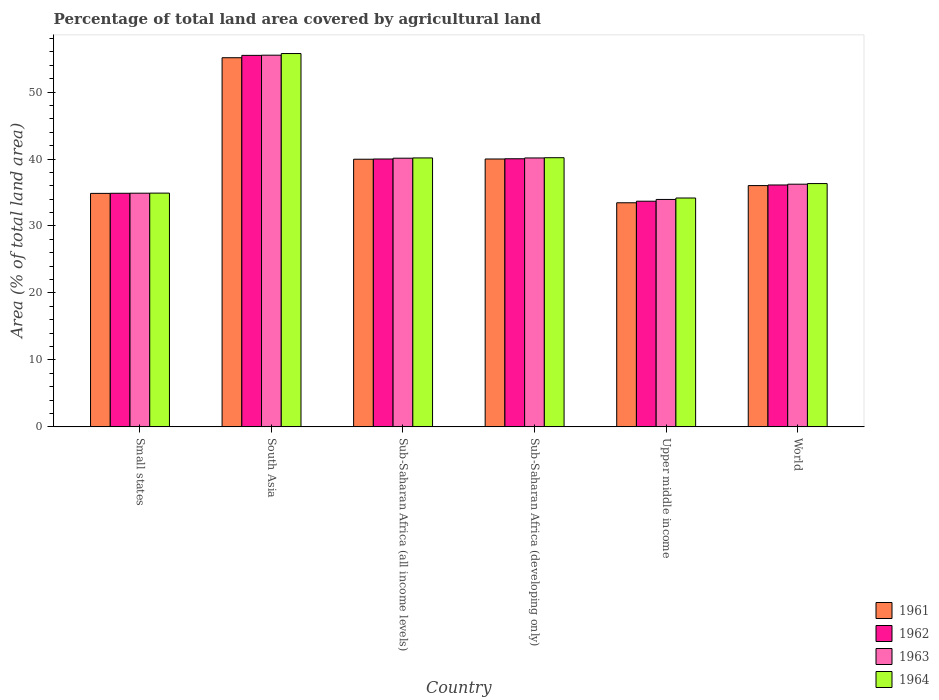How many different coloured bars are there?
Give a very brief answer. 4. How many groups of bars are there?
Ensure brevity in your answer.  6. Are the number of bars per tick equal to the number of legend labels?
Provide a succinct answer. Yes. How many bars are there on the 2nd tick from the left?
Provide a short and direct response. 4. How many bars are there on the 6th tick from the right?
Give a very brief answer. 4. What is the label of the 1st group of bars from the left?
Your response must be concise. Small states. What is the percentage of agricultural land in 1962 in South Asia?
Your answer should be very brief. 55.48. Across all countries, what is the maximum percentage of agricultural land in 1961?
Offer a very short reply. 55.13. Across all countries, what is the minimum percentage of agricultural land in 1963?
Provide a short and direct response. 33.96. In which country was the percentage of agricultural land in 1963 maximum?
Your response must be concise. South Asia. In which country was the percentage of agricultural land in 1962 minimum?
Give a very brief answer. Upper middle income. What is the total percentage of agricultural land in 1963 in the graph?
Ensure brevity in your answer.  240.89. What is the difference between the percentage of agricultural land in 1961 in Small states and that in Upper middle income?
Keep it short and to the point. 1.4. What is the difference between the percentage of agricultural land in 1962 in Sub-Saharan Africa (all income levels) and the percentage of agricultural land in 1964 in World?
Your answer should be very brief. 3.67. What is the average percentage of agricultural land in 1964 per country?
Your answer should be compact. 40.26. What is the difference between the percentage of agricultural land of/in 1964 and percentage of agricultural land of/in 1962 in Upper middle income?
Provide a short and direct response. 0.48. In how many countries, is the percentage of agricultural land in 1962 greater than 10 %?
Your response must be concise. 6. What is the ratio of the percentage of agricultural land in 1962 in Sub-Saharan Africa (all income levels) to that in Sub-Saharan Africa (developing only)?
Your answer should be compact. 1. Is the percentage of agricultural land in 1962 in Sub-Saharan Africa (all income levels) less than that in Upper middle income?
Keep it short and to the point. No. Is the difference between the percentage of agricultural land in 1964 in Small states and Sub-Saharan Africa (all income levels) greater than the difference between the percentage of agricultural land in 1962 in Small states and Sub-Saharan Africa (all income levels)?
Offer a terse response. No. What is the difference between the highest and the second highest percentage of agricultural land in 1964?
Provide a succinct answer. 0.03. What is the difference between the highest and the lowest percentage of agricultural land in 1964?
Make the answer very short. 21.57. In how many countries, is the percentage of agricultural land in 1961 greater than the average percentage of agricultural land in 1961 taken over all countries?
Provide a short and direct response. 3. Is it the case that in every country, the sum of the percentage of agricultural land in 1962 and percentage of agricultural land in 1964 is greater than the sum of percentage of agricultural land in 1963 and percentage of agricultural land in 1961?
Provide a succinct answer. No. What does the 4th bar from the left in Sub-Saharan Africa (all income levels) represents?
Make the answer very short. 1964. How many bars are there?
Your answer should be compact. 24. Are all the bars in the graph horizontal?
Your answer should be very brief. No. Are the values on the major ticks of Y-axis written in scientific E-notation?
Offer a very short reply. No. Where does the legend appear in the graph?
Your answer should be very brief. Bottom right. How are the legend labels stacked?
Ensure brevity in your answer.  Vertical. What is the title of the graph?
Your response must be concise. Percentage of total land area covered by agricultural land. Does "1987" appear as one of the legend labels in the graph?
Keep it short and to the point. No. What is the label or title of the Y-axis?
Give a very brief answer. Area (% of total land area). What is the Area (% of total land area) of 1961 in Small states?
Provide a short and direct response. 34.87. What is the Area (% of total land area) in 1962 in Small states?
Offer a very short reply. 34.88. What is the Area (% of total land area) in 1963 in Small states?
Provide a short and direct response. 34.9. What is the Area (% of total land area) of 1964 in Small states?
Ensure brevity in your answer.  34.91. What is the Area (% of total land area) of 1961 in South Asia?
Provide a short and direct response. 55.13. What is the Area (% of total land area) in 1962 in South Asia?
Offer a terse response. 55.48. What is the Area (% of total land area) of 1963 in South Asia?
Keep it short and to the point. 55.51. What is the Area (% of total land area) of 1964 in South Asia?
Give a very brief answer. 55.75. What is the Area (% of total land area) in 1961 in Sub-Saharan Africa (all income levels)?
Offer a terse response. 39.97. What is the Area (% of total land area) in 1962 in Sub-Saharan Africa (all income levels)?
Your answer should be very brief. 40. What is the Area (% of total land area) in 1963 in Sub-Saharan Africa (all income levels)?
Your answer should be very brief. 40.12. What is the Area (% of total land area) in 1964 in Sub-Saharan Africa (all income levels)?
Provide a succinct answer. 40.16. What is the Area (% of total land area) in 1961 in Sub-Saharan Africa (developing only)?
Your response must be concise. 40. What is the Area (% of total land area) in 1962 in Sub-Saharan Africa (developing only)?
Your answer should be compact. 40.04. What is the Area (% of total land area) of 1963 in Sub-Saharan Africa (developing only)?
Make the answer very short. 40.16. What is the Area (% of total land area) of 1964 in Sub-Saharan Africa (developing only)?
Ensure brevity in your answer.  40.2. What is the Area (% of total land area) in 1961 in Upper middle income?
Provide a succinct answer. 33.47. What is the Area (% of total land area) in 1962 in Upper middle income?
Offer a very short reply. 33.7. What is the Area (% of total land area) in 1963 in Upper middle income?
Provide a succinct answer. 33.96. What is the Area (% of total land area) of 1964 in Upper middle income?
Give a very brief answer. 34.18. What is the Area (% of total land area) of 1961 in World?
Provide a short and direct response. 36.03. What is the Area (% of total land area) of 1962 in World?
Offer a terse response. 36.12. What is the Area (% of total land area) of 1963 in World?
Provide a succinct answer. 36.24. What is the Area (% of total land area) in 1964 in World?
Your answer should be very brief. 36.33. Across all countries, what is the maximum Area (% of total land area) of 1961?
Give a very brief answer. 55.13. Across all countries, what is the maximum Area (% of total land area) in 1962?
Offer a very short reply. 55.48. Across all countries, what is the maximum Area (% of total land area) in 1963?
Offer a very short reply. 55.51. Across all countries, what is the maximum Area (% of total land area) of 1964?
Your response must be concise. 55.75. Across all countries, what is the minimum Area (% of total land area) in 1961?
Your response must be concise. 33.47. Across all countries, what is the minimum Area (% of total land area) in 1962?
Provide a short and direct response. 33.7. Across all countries, what is the minimum Area (% of total land area) of 1963?
Offer a terse response. 33.96. Across all countries, what is the minimum Area (% of total land area) in 1964?
Ensure brevity in your answer.  34.18. What is the total Area (% of total land area) in 1961 in the graph?
Ensure brevity in your answer.  239.47. What is the total Area (% of total land area) in 1962 in the graph?
Offer a very short reply. 240.23. What is the total Area (% of total land area) in 1963 in the graph?
Give a very brief answer. 240.89. What is the total Area (% of total land area) of 1964 in the graph?
Your response must be concise. 241.53. What is the difference between the Area (% of total land area) of 1961 in Small states and that in South Asia?
Make the answer very short. -20.26. What is the difference between the Area (% of total land area) of 1962 in Small states and that in South Asia?
Your response must be concise. -20.6. What is the difference between the Area (% of total land area) in 1963 in Small states and that in South Asia?
Give a very brief answer. -20.61. What is the difference between the Area (% of total land area) in 1964 in Small states and that in South Asia?
Your answer should be compact. -20.84. What is the difference between the Area (% of total land area) in 1961 in Small states and that in Sub-Saharan Africa (all income levels)?
Your answer should be compact. -5.1. What is the difference between the Area (% of total land area) in 1962 in Small states and that in Sub-Saharan Africa (all income levels)?
Offer a terse response. -5.12. What is the difference between the Area (% of total land area) in 1963 in Small states and that in Sub-Saharan Africa (all income levels)?
Give a very brief answer. -5.23. What is the difference between the Area (% of total land area) of 1964 in Small states and that in Sub-Saharan Africa (all income levels)?
Your answer should be compact. -5.25. What is the difference between the Area (% of total land area) of 1961 in Small states and that in Sub-Saharan Africa (developing only)?
Your answer should be compact. -5.13. What is the difference between the Area (% of total land area) of 1962 in Small states and that in Sub-Saharan Africa (developing only)?
Provide a short and direct response. -5.15. What is the difference between the Area (% of total land area) in 1963 in Small states and that in Sub-Saharan Africa (developing only)?
Provide a succinct answer. -5.26. What is the difference between the Area (% of total land area) in 1964 in Small states and that in Sub-Saharan Africa (developing only)?
Your answer should be compact. -5.29. What is the difference between the Area (% of total land area) in 1961 in Small states and that in Upper middle income?
Keep it short and to the point. 1.4. What is the difference between the Area (% of total land area) in 1962 in Small states and that in Upper middle income?
Make the answer very short. 1.18. What is the difference between the Area (% of total land area) of 1963 in Small states and that in Upper middle income?
Your answer should be compact. 0.93. What is the difference between the Area (% of total land area) of 1964 in Small states and that in Upper middle income?
Provide a short and direct response. 0.73. What is the difference between the Area (% of total land area) in 1961 in Small states and that in World?
Provide a short and direct response. -1.16. What is the difference between the Area (% of total land area) of 1962 in Small states and that in World?
Your response must be concise. -1.24. What is the difference between the Area (% of total land area) of 1963 in Small states and that in World?
Provide a succinct answer. -1.34. What is the difference between the Area (% of total land area) of 1964 in Small states and that in World?
Your response must be concise. -1.43. What is the difference between the Area (% of total land area) of 1961 in South Asia and that in Sub-Saharan Africa (all income levels)?
Provide a succinct answer. 15.16. What is the difference between the Area (% of total land area) of 1962 in South Asia and that in Sub-Saharan Africa (all income levels)?
Make the answer very short. 15.48. What is the difference between the Area (% of total land area) of 1963 in South Asia and that in Sub-Saharan Africa (all income levels)?
Your response must be concise. 15.38. What is the difference between the Area (% of total land area) of 1964 in South Asia and that in Sub-Saharan Africa (all income levels)?
Keep it short and to the point. 15.59. What is the difference between the Area (% of total land area) of 1961 in South Asia and that in Sub-Saharan Africa (developing only)?
Keep it short and to the point. 15.12. What is the difference between the Area (% of total land area) in 1962 in South Asia and that in Sub-Saharan Africa (developing only)?
Provide a succinct answer. 15.44. What is the difference between the Area (% of total land area) of 1963 in South Asia and that in Sub-Saharan Africa (developing only)?
Ensure brevity in your answer.  15.35. What is the difference between the Area (% of total land area) of 1964 in South Asia and that in Sub-Saharan Africa (developing only)?
Give a very brief answer. 15.56. What is the difference between the Area (% of total land area) of 1961 in South Asia and that in Upper middle income?
Offer a very short reply. 21.66. What is the difference between the Area (% of total land area) of 1962 in South Asia and that in Upper middle income?
Your answer should be compact. 21.78. What is the difference between the Area (% of total land area) in 1963 in South Asia and that in Upper middle income?
Provide a short and direct response. 21.54. What is the difference between the Area (% of total land area) of 1964 in South Asia and that in Upper middle income?
Your answer should be compact. 21.57. What is the difference between the Area (% of total land area) of 1961 in South Asia and that in World?
Your answer should be compact. 19.1. What is the difference between the Area (% of total land area) of 1962 in South Asia and that in World?
Make the answer very short. 19.36. What is the difference between the Area (% of total land area) of 1963 in South Asia and that in World?
Provide a succinct answer. 19.27. What is the difference between the Area (% of total land area) of 1964 in South Asia and that in World?
Keep it short and to the point. 19.42. What is the difference between the Area (% of total land area) in 1961 in Sub-Saharan Africa (all income levels) and that in Sub-Saharan Africa (developing only)?
Your response must be concise. -0.03. What is the difference between the Area (% of total land area) in 1962 in Sub-Saharan Africa (all income levels) and that in Sub-Saharan Africa (developing only)?
Your answer should be very brief. -0.03. What is the difference between the Area (% of total land area) of 1963 in Sub-Saharan Africa (all income levels) and that in Sub-Saharan Africa (developing only)?
Offer a terse response. -0.03. What is the difference between the Area (% of total land area) in 1964 in Sub-Saharan Africa (all income levels) and that in Sub-Saharan Africa (developing only)?
Provide a short and direct response. -0.03. What is the difference between the Area (% of total land area) in 1961 in Sub-Saharan Africa (all income levels) and that in Upper middle income?
Your answer should be very brief. 6.5. What is the difference between the Area (% of total land area) of 1962 in Sub-Saharan Africa (all income levels) and that in Upper middle income?
Your response must be concise. 6.3. What is the difference between the Area (% of total land area) of 1963 in Sub-Saharan Africa (all income levels) and that in Upper middle income?
Provide a short and direct response. 6.16. What is the difference between the Area (% of total land area) in 1964 in Sub-Saharan Africa (all income levels) and that in Upper middle income?
Offer a very short reply. 5.98. What is the difference between the Area (% of total land area) in 1961 in Sub-Saharan Africa (all income levels) and that in World?
Your response must be concise. 3.94. What is the difference between the Area (% of total land area) of 1962 in Sub-Saharan Africa (all income levels) and that in World?
Your answer should be very brief. 3.88. What is the difference between the Area (% of total land area) of 1963 in Sub-Saharan Africa (all income levels) and that in World?
Offer a very short reply. 3.88. What is the difference between the Area (% of total land area) of 1964 in Sub-Saharan Africa (all income levels) and that in World?
Give a very brief answer. 3.83. What is the difference between the Area (% of total land area) of 1961 in Sub-Saharan Africa (developing only) and that in Upper middle income?
Offer a terse response. 6.54. What is the difference between the Area (% of total land area) of 1962 in Sub-Saharan Africa (developing only) and that in Upper middle income?
Provide a short and direct response. 6.34. What is the difference between the Area (% of total land area) of 1963 in Sub-Saharan Africa (developing only) and that in Upper middle income?
Your answer should be compact. 6.2. What is the difference between the Area (% of total land area) of 1964 in Sub-Saharan Africa (developing only) and that in Upper middle income?
Offer a very short reply. 6.02. What is the difference between the Area (% of total land area) of 1961 in Sub-Saharan Africa (developing only) and that in World?
Give a very brief answer. 3.97. What is the difference between the Area (% of total land area) of 1962 in Sub-Saharan Africa (developing only) and that in World?
Offer a terse response. 3.91. What is the difference between the Area (% of total land area) in 1963 in Sub-Saharan Africa (developing only) and that in World?
Make the answer very short. 3.92. What is the difference between the Area (% of total land area) in 1964 in Sub-Saharan Africa (developing only) and that in World?
Make the answer very short. 3.86. What is the difference between the Area (% of total land area) in 1961 in Upper middle income and that in World?
Ensure brevity in your answer.  -2.57. What is the difference between the Area (% of total land area) in 1962 in Upper middle income and that in World?
Your response must be concise. -2.42. What is the difference between the Area (% of total land area) of 1963 in Upper middle income and that in World?
Give a very brief answer. -2.28. What is the difference between the Area (% of total land area) of 1964 in Upper middle income and that in World?
Your answer should be very brief. -2.15. What is the difference between the Area (% of total land area) in 1961 in Small states and the Area (% of total land area) in 1962 in South Asia?
Provide a succinct answer. -20.61. What is the difference between the Area (% of total land area) of 1961 in Small states and the Area (% of total land area) of 1963 in South Asia?
Your response must be concise. -20.64. What is the difference between the Area (% of total land area) in 1961 in Small states and the Area (% of total land area) in 1964 in South Asia?
Your answer should be very brief. -20.88. What is the difference between the Area (% of total land area) of 1962 in Small states and the Area (% of total land area) of 1963 in South Asia?
Your response must be concise. -20.62. What is the difference between the Area (% of total land area) in 1962 in Small states and the Area (% of total land area) in 1964 in South Asia?
Keep it short and to the point. -20.87. What is the difference between the Area (% of total land area) of 1963 in Small states and the Area (% of total land area) of 1964 in South Asia?
Keep it short and to the point. -20.86. What is the difference between the Area (% of total land area) of 1961 in Small states and the Area (% of total land area) of 1962 in Sub-Saharan Africa (all income levels)?
Your answer should be compact. -5.13. What is the difference between the Area (% of total land area) in 1961 in Small states and the Area (% of total land area) in 1963 in Sub-Saharan Africa (all income levels)?
Your response must be concise. -5.25. What is the difference between the Area (% of total land area) in 1961 in Small states and the Area (% of total land area) in 1964 in Sub-Saharan Africa (all income levels)?
Provide a succinct answer. -5.29. What is the difference between the Area (% of total land area) of 1962 in Small states and the Area (% of total land area) of 1963 in Sub-Saharan Africa (all income levels)?
Make the answer very short. -5.24. What is the difference between the Area (% of total land area) of 1962 in Small states and the Area (% of total land area) of 1964 in Sub-Saharan Africa (all income levels)?
Make the answer very short. -5.28. What is the difference between the Area (% of total land area) of 1963 in Small states and the Area (% of total land area) of 1964 in Sub-Saharan Africa (all income levels)?
Offer a very short reply. -5.27. What is the difference between the Area (% of total land area) in 1961 in Small states and the Area (% of total land area) in 1962 in Sub-Saharan Africa (developing only)?
Give a very brief answer. -5.17. What is the difference between the Area (% of total land area) in 1961 in Small states and the Area (% of total land area) in 1963 in Sub-Saharan Africa (developing only)?
Your response must be concise. -5.29. What is the difference between the Area (% of total land area) of 1961 in Small states and the Area (% of total land area) of 1964 in Sub-Saharan Africa (developing only)?
Keep it short and to the point. -5.33. What is the difference between the Area (% of total land area) in 1962 in Small states and the Area (% of total land area) in 1963 in Sub-Saharan Africa (developing only)?
Give a very brief answer. -5.27. What is the difference between the Area (% of total land area) in 1962 in Small states and the Area (% of total land area) in 1964 in Sub-Saharan Africa (developing only)?
Offer a very short reply. -5.31. What is the difference between the Area (% of total land area) in 1963 in Small states and the Area (% of total land area) in 1964 in Sub-Saharan Africa (developing only)?
Keep it short and to the point. -5.3. What is the difference between the Area (% of total land area) of 1961 in Small states and the Area (% of total land area) of 1962 in Upper middle income?
Offer a terse response. 1.17. What is the difference between the Area (% of total land area) in 1961 in Small states and the Area (% of total land area) in 1963 in Upper middle income?
Give a very brief answer. 0.91. What is the difference between the Area (% of total land area) in 1961 in Small states and the Area (% of total land area) in 1964 in Upper middle income?
Give a very brief answer. 0.69. What is the difference between the Area (% of total land area) in 1962 in Small states and the Area (% of total land area) in 1963 in Upper middle income?
Make the answer very short. 0.92. What is the difference between the Area (% of total land area) of 1962 in Small states and the Area (% of total land area) of 1964 in Upper middle income?
Ensure brevity in your answer.  0.71. What is the difference between the Area (% of total land area) of 1963 in Small states and the Area (% of total land area) of 1964 in Upper middle income?
Provide a succinct answer. 0.72. What is the difference between the Area (% of total land area) in 1961 in Small states and the Area (% of total land area) in 1962 in World?
Your answer should be compact. -1.25. What is the difference between the Area (% of total land area) in 1961 in Small states and the Area (% of total land area) in 1963 in World?
Make the answer very short. -1.37. What is the difference between the Area (% of total land area) of 1961 in Small states and the Area (% of total land area) of 1964 in World?
Ensure brevity in your answer.  -1.46. What is the difference between the Area (% of total land area) of 1962 in Small states and the Area (% of total land area) of 1963 in World?
Your answer should be compact. -1.36. What is the difference between the Area (% of total land area) of 1962 in Small states and the Area (% of total land area) of 1964 in World?
Provide a succinct answer. -1.45. What is the difference between the Area (% of total land area) of 1963 in Small states and the Area (% of total land area) of 1964 in World?
Offer a terse response. -1.44. What is the difference between the Area (% of total land area) in 1961 in South Asia and the Area (% of total land area) in 1962 in Sub-Saharan Africa (all income levels)?
Your response must be concise. 15.12. What is the difference between the Area (% of total land area) in 1961 in South Asia and the Area (% of total land area) in 1963 in Sub-Saharan Africa (all income levels)?
Ensure brevity in your answer.  15. What is the difference between the Area (% of total land area) of 1961 in South Asia and the Area (% of total land area) of 1964 in Sub-Saharan Africa (all income levels)?
Your response must be concise. 14.97. What is the difference between the Area (% of total land area) in 1962 in South Asia and the Area (% of total land area) in 1963 in Sub-Saharan Africa (all income levels)?
Provide a succinct answer. 15.36. What is the difference between the Area (% of total land area) of 1962 in South Asia and the Area (% of total land area) of 1964 in Sub-Saharan Africa (all income levels)?
Provide a succinct answer. 15.32. What is the difference between the Area (% of total land area) in 1963 in South Asia and the Area (% of total land area) in 1964 in Sub-Saharan Africa (all income levels)?
Keep it short and to the point. 15.35. What is the difference between the Area (% of total land area) in 1961 in South Asia and the Area (% of total land area) in 1962 in Sub-Saharan Africa (developing only)?
Provide a succinct answer. 15.09. What is the difference between the Area (% of total land area) of 1961 in South Asia and the Area (% of total land area) of 1963 in Sub-Saharan Africa (developing only)?
Your answer should be compact. 14.97. What is the difference between the Area (% of total land area) of 1961 in South Asia and the Area (% of total land area) of 1964 in Sub-Saharan Africa (developing only)?
Offer a terse response. 14.93. What is the difference between the Area (% of total land area) in 1962 in South Asia and the Area (% of total land area) in 1963 in Sub-Saharan Africa (developing only)?
Offer a terse response. 15.32. What is the difference between the Area (% of total land area) of 1962 in South Asia and the Area (% of total land area) of 1964 in Sub-Saharan Africa (developing only)?
Your response must be concise. 15.28. What is the difference between the Area (% of total land area) in 1963 in South Asia and the Area (% of total land area) in 1964 in Sub-Saharan Africa (developing only)?
Give a very brief answer. 15.31. What is the difference between the Area (% of total land area) of 1961 in South Asia and the Area (% of total land area) of 1962 in Upper middle income?
Offer a very short reply. 21.43. What is the difference between the Area (% of total land area) in 1961 in South Asia and the Area (% of total land area) in 1963 in Upper middle income?
Ensure brevity in your answer.  21.17. What is the difference between the Area (% of total land area) in 1961 in South Asia and the Area (% of total land area) in 1964 in Upper middle income?
Offer a very short reply. 20.95. What is the difference between the Area (% of total land area) of 1962 in South Asia and the Area (% of total land area) of 1963 in Upper middle income?
Provide a succinct answer. 21.52. What is the difference between the Area (% of total land area) in 1962 in South Asia and the Area (% of total land area) in 1964 in Upper middle income?
Ensure brevity in your answer.  21.3. What is the difference between the Area (% of total land area) of 1963 in South Asia and the Area (% of total land area) of 1964 in Upper middle income?
Provide a succinct answer. 21.33. What is the difference between the Area (% of total land area) in 1961 in South Asia and the Area (% of total land area) in 1962 in World?
Provide a succinct answer. 19. What is the difference between the Area (% of total land area) of 1961 in South Asia and the Area (% of total land area) of 1963 in World?
Ensure brevity in your answer.  18.89. What is the difference between the Area (% of total land area) of 1961 in South Asia and the Area (% of total land area) of 1964 in World?
Make the answer very short. 18.79. What is the difference between the Area (% of total land area) in 1962 in South Asia and the Area (% of total land area) in 1963 in World?
Provide a succinct answer. 19.24. What is the difference between the Area (% of total land area) in 1962 in South Asia and the Area (% of total land area) in 1964 in World?
Give a very brief answer. 19.15. What is the difference between the Area (% of total land area) in 1963 in South Asia and the Area (% of total land area) in 1964 in World?
Make the answer very short. 19.17. What is the difference between the Area (% of total land area) in 1961 in Sub-Saharan Africa (all income levels) and the Area (% of total land area) in 1962 in Sub-Saharan Africa (developing only)?
Provide a short and direct response. -0.07. What is the difference between the Area (% of total land area) of 1961 in Sub-Saharan Africa (all income levels) and the Area (% of total land area) of 1963 in Sub-Saharan Africa (developing only)?
Give a very brief answer. -0.19. What is the difference between the Area (% of total land area) in 1961 in Sub-Saharan Africa (all income levels) and the Area (% of total land area) in 1964 in Sub-Saharan Africa (developing only)?
Keep it short and to the point. -0.23. What is the difference between the Area (% of total land area) in 1962 in Sub-Saharan Africa (all income levels) and the Area (% of total land area) in 1963 in Sub-Saharan Africa (developing only)?
Provide a succinct answer. -0.15. What is the difference between the Area (% of total land area) of 1962 in Sub-Saharan Africa (all income levels) and the Area (% of total land area) of 1964 in Sub-Saharan Africa (developing only)?
Give a very brief answer. -0.19. What is the difference between the Area (% of total land area) of 1963 in Sub-Saharan Africa (all income levels) and the Area (% of total land area) of 1964 in Sub-Saharan Africa (developing only)?
Offer a very short reply. -0.07. What is the difference between the Area (% of total land area) of 1961 in Sub-Saharan Africa (all income levels) and the Area (% of total land area) of 1962 in Upper middle income?
Provide a short and direct response. 6.27. What is the difference between the Area (% of total land area) of 1961 in Sub-Saharan Africa (all income levels) and the Area (% of total land area) of 1963 in Upper middle income?
Offer a very short reply. 6.01. What is the difference between the Area (% of total land area) in 1961 in Sub-Saharan Africa (all income levels) and the Area (% of total land area) in 1964 in Upper middle income?
Your answer should be very brief. 5.79. What is the difference between the Area (% of total land area) in 1962 in Sub-Saharan Africa (all income levels) and the Area (% of total land area) in 1963 in Upper middle income?
Offer a very short reply. 6.04. What is the difference between the Area (% of total land area) in 1962 in Sub-Saharan Africa (all income levels) and the Area (% of total land area) in 1964 in Upper middle income?
Give a very brief answer. 5.82. What is the difference between the Area (% of total land area) of 1963 in Sub-Saharan Africa (all income levels) and the Area (% of total land area) of 1964 in Upper middle income?
Keep it short and to the point. 5.95. What is the difference between the Area (% of total land area) in 1961 in Sub-Saharan Africa (all income levels) and the Area (% of total land area) in 1962 in World?
Your answer should be very brief. 3.84. What is the difference between the Area (% of total land area) in 1961 in Sub-Saharan Africa (all income levels) and the Area (% of total land area) in 1963 in World?
Give a very brief answer. 3.73. What is the difference between the Area (% of total land area) of 1961 in Sub-Saharan Africa (all income levels) and the Area (% of total land area) of 1964 in World?
Keep it short and to the point. 3.64. What is the difference between the Area (% of total land area) of 1962 in Sub-Saharan Africa (all income levels) and the Area (% of total land area) of 1963 in World?
Provide a short and direct response. 3.76. What is the difference between the Area (% of total land area) of 1962 in Sub-Saharan Africa (all income levels) and the Area (% of total land area) of 1964 in World?
Your answer should be compact. 3.67. What is the difference between the Area (% of total land area) in 1963 in Sub-Saharan Africa (all income levels) and the Area (% of total land area) in 1964 in World?
Your answer should be compact. 3.79. What is the difference between the Area (% of total land area) of 1961 in Sub-Saharan Africa (developing only) and the Area (% of total land area) of 1962 in Upper middle income?
Your response must be concise. 6.3. What is the difference between the Area (% of total land area) of 1961 in Sub-Saharan Africa (developing only) and the Area (% of total land area) of 1963 in Upper middle income?
Provide a short and direct response. 6.04. What is the difference between the Area (% of total land area) of 1961 in Sub-Saharan Africa (developing only) and the Area (% of total land area) of 1964 in Upper middle income?
Offer a terse response. 5.82. What is the difference between the Area (% of total land area) in 1962 in Sub-Saharan Africa (developing only) and the Area (% of total land area) in 1963 in Upper middle income?
Provide a succinct answer. 6.08. What is the difference between the Area (% of total land area) in 1962 in Sub-Saharan Africa (developing only) and the Area (% of total land area) in 1964 in Upper middle income?
Provide a short and direct response. 5.86. What is the difference between the Area (% of total land area) of 1963 in Sub-Saharan Africa (developing only) and the Area (% of total land area) of 1964 in Upper middle income?
Offer a very short reply. 5.98. What is the difference between the Area (% of total land area) in 1961 in Sub-Saharan Africa (developing only) and the Area (% of total land area) in 1962 in World?
Ensure brevity in your answer.  3.88. What is the difference between the Area (% of total land area) in 1961 in Sub-Saharan Africa (developing only) and the Area (% of total land area) in 1963 in World?
Your response must be concise. 3.76. What is the difference between the Area (% of total land area) of 1961 in Sub-Saharan Africa (developing only) and the Area (% of total land area) of 1964 in World?
Offer a very short reply. 3.67. What is the difference between the Area (% of total land area) in 1962 in Sub-Saharan Africa (developing only) and the Area (% of total land area) in 1963 in World?
Your answer should be compact. 3.8. What is the difference between the Area (% of total land area) of 1962 in Sub-Saharan Africa (developing only) and the Area (% of total land area) of 1964 in World?
Your answer should be compact. 3.7. What is the difference between the Area (% of total land area) of 1963 in Sub-Saharan Africa (developing only) and the Area (% of total land area) of 1964 in World?
Provide a short and direct response. 3.83. What is the difference between the Area (% of total land area) in 1961 in Upper middle income and the Area (% of total land area) in 1962 in World?
Ensure brevity in your answer.  -2.66. What is the difference between the Area (% of total land area) in 1961 in Upper middle income and the Area (% of total land area) in 1963 in World?
Your response must be concise. -2.77. What is the difference between the Area (% of total land area) of 1961 in Upper middle income and the Area (% of total land area) of 1964 in World?
Keep it short and to the point. -2.87. What is the difference between the Area (% of total land area) in 1962 in Upper middle income and the Area (% of total land area) in 1963 in World?
Provide a succinct answer. -2.54. What is the difference between the Area (% of total land area) of 1962 in Upper middle income and the Area (% of total land area) of 1964 in World?
Ensure brevity in your answer.  -2.63. What is the difference between the Area (% of total land area) of 1963 in Upper middle income and the Area (% of total land area) of 1964 in World?
Provide a short and direct response. -2.37. What is the average Area (% of total land area) in 1961 per country?
Offer a terse response. 39.91. What is the average Area (% of total land area) in 1962 per country?
Give a very brief answer. 40.04. What is the average Area (% of total land area) in 1963 per country?
Provide a succinct answer. 40.15. What is the average Area (% of total land area) of 1964 per country?
Your answer should be compact. 40.26. What is the difference between the Area (% of total land area) of 1961 and Area (% of total land area) of 1962 in Small states?
Offer a terse response. -0.01. What is the difference between the Area (% of total land area) of 1961 and Area (% of total land area) of 1963 in Small states?
Offer a very short reply. -0.03. What is the difference between the Area (% of total land area) in 1961 and Area (% of total land area) in 1964 in Small states?
Provide a short and direct response. -0.04. What is the difference between the Area (% of total land area) of 1962 and Area (% of total land area) of 1963 in Small states?
Keep it short and to the point. -0.01. What is the difference between the Area (% of total land area) in 1962 and Area (% of total land area) in 1964 in Small states?
Make the answer very short. -0.02. What is the difference between the Area (% of total land area) of 1963 and Area (% of total land area) of 1964 in Small states?
Ensure brevity in your answer.  -0.01. What is the difference between the Area (% of total land area) of 1961 and Area (% of total land area) of 1962 in South Asia?
Make the answer very short. -0.35. What is the difference between the Area (% of total land area) in 1961 and Area (% of total land area) in 1963 in South Asia?
Make the answer very short. -0.38. What is the difference between the Area (% of total land area) of 1961 and Area (% of total land area) of 1964 in South Asia?
Keep it short and to the point. -0.62. What is the difference between the Area (% of total land area) of 1962 and Area (% of total land area) of 1963 in South Asia?
Keep it short and to the point. -0.03. What is the difference between the Area (% of total land area) of 1962 and Area (% of total land area) of 1964 in South Asia?
Give a very brief answer. -0.27. What is the difference between the Area (% of total land area) of 1963 and Area (% of total land area) of 1964 in South Asia?
Give a very brief answer. -0.24. What is the difference between the Area (% of total land area) in 1961 and Area (% of total land area) in 1962 in Sub-Saharan Africa (all income levels)?
Offer a terse response. -0.04. What is the difference between the Area (% of total land area) in 1961 and Area (% of total land area) in 1963 in Sub-Saharan Africa (all income levels)?
Your answer should be compact. -0.16. What is the difference between the Area (% of total land area) in 1961 and Area (% of total land area) in 1964 in Sub-Saharan Africa (all income levels)?
Give a very brief answer. -0.19. What is the difference between the Area (% of total land area) in 1962 and Area (% of total land area) in 1963 in Sub-Saharan Africa (all income levels)?
Give a very brief answer. -0.12. What is the difference between the Area (% of total land area) in 1962 and Area (% of total land area) in 1964 in Sub-Saharan Africa (all income levels)?
Ensure brevity in your answer.  -0.16. What is the difference between the Area (% of total land area) of 1963 and Area (% of total land area) of 1964 in Sub-Saharan Africa (all income levels)?
Your response must be concise. -0.04. What is the difference between the Area (% of total land area) of 1961 and Area (% of total land area) of 1962 in Sub-Saharan Africa (developing only)?
Give a very brief answer. -0.03. What is the difference between the Area (% of total land area) in 1961 and Area (% of total land area) in 1963 in Sub-Saharan Africa (developing only)?
Your response must be concise. -0.16. What is the difference between the Area (% of total land area) of 1961 and Area (% of total land area) of 1964 in Sub-Saharan Africa (developing only)?
Your response must be concise. -0.19. What is the difference between the Area (% of total land area) in 1962 and Area (% of total land area) in 1963 in Sub-Saharan Africa (developing only)?
Provide a succinct answer. -0.12. What is the difference between the Area (% of total land area) of 1962 and Area (% of total land area) of 1964 in Sub-Saharan Africa (developing only)?
Offer a terse response. -0.16. What is the difference between the Area (% of total land area) of 1963 and Area (% of total land area) of 1964 in Sub-Saharan Africa (developing only)?
Provide a succinct answer. -0.04. What is the difference between the Area (% of total land area) of 1961 and Area (% of total land area) of 1962 in Upper middle income?
Ensure brevity in your answer.  -0.23. What is the difference between the Area (% of total land area) of 1961 and Area (% of total land area) of 1963 in Upper middle income?
Your answer should be compact. -0.5. What is the difference between the Area (% of total land area) in 1961 and Area (% of total land area) in 1964 in Upper middle income?
Offer a terse response. -0.71. What is the difference between the Area (% of total land area) of 1962 and Area (% of total land area) of 1963 in Upper middle income?
Give a very brief answer. -0.26. What is the difference between the Area (% of total land area) in 1962 and Area (% of total land area) in 1964 in Upper middle income?
Give a very brief answer. -0.48. What is the difference between the Area (% of total land area) in 1963 and Area (% of total land area) in 1964 in Upper middle income?
Your answer should be very brief. -0.22. What is the difference between the Area (% of total land area) in 1961 and Area (% of total land area) in 1962 in World?
Provide a short and direct response. -0.09. What is the difference between the Area (% of total land area) in 1961 and Area (% of total land area) in 1963 in World?
Your answer should be very brief. -0.21. What is the difference between the Area (% of total land area) in 1961 and Area (% of total land area) in 1964 in World?
Your answer should be very brief. -0.3. What is the difference between the Area (% of total land area) in 1962 and Area (% of total land area) in 1963 in World?
Provide a short and direct response. -0.12. What is the difference between the Area (% of total land area) in 1962 and Area (% of total land area) in 1964 in World?
Your answer should be very brief. -0.21. What is the difference between the Area (% of total land area) in 1963 and Area (% of total land area) in 1964 in World?
Offer a terse response. -0.09. What is the ratio of the Area (% of total land area) in 1961 in Small states to that in South Asia?
Provide a short and direct response. 0.63. What is the ratio of the Area (% of total land area) of 1962 in Small states to that in South Asia?
Provide a short and direct response. 0.63. What is the ratio of the Area (% of total land area) in 1963 in Small states to that in South Asia?
Keep it short and to the point. 0.63. What is the ratio of the Area (% of total land area) of 1964 in Small states to that in South Asia?
Offer a very short reply. 0.63. What is the ratio of the Area (% of total land area) of 1961 in Small states to that in Sub-Saharan Africa (all income levels)?
Offer a very short reply. 0.87. What is the ratio of the Area (% of total land area) in 1962 in Small states to that in Sub-Saharan Africa (all income levels)?
Provide a short and direct response. 0.87. What is the ratio of the Area (% of total land area) in 1963 in Small states to that in Sub-Saharan Africa (all income levels)?
Your answer should be very brief. 0.87. What is the ratio of the Area (% of total land area) in 1964 in Small states to that in Sub-Saharan Africa (all income levels)?
Provide a succinct answer. 0.87. What is the ratio of the Area (% of total land area) in 1961 in Small states to that in Sub-Saharan Africa (developing only)?
Offer a terse response. 0.87. What is the ratio of the Area (% of total land area) of 1962 in Small states to that in Sub-Saharan Africa (developing only)?
Ensure brevity in your answer.  0.87. What is the ratio of the Area (% of total land area) of 1963 in Small states to that in Sub-Saharan Africa (developing only)?
Provide a short and direct response. 0.87. What is the ratio of the Area (% of total land area) of 1964 in Small states to that in Sub-Saharan Africa (developing only)?
Keep it short and to the point. 0.87. What is the ratio of the Area (% of total land area) of 1961 in Small states to that in Upper middle income?
Provide a short and direct response. 1.04. What is the ratio of the Area (% of total land area) in 1962 in Small states to that in Upper middle income?
Make the answer very short. 1.04. What is the ratio of the Area (% of total land area) of 1963 in Small states to that in Upper middle income?
Offer a terse response. 1.03. What is the ratio of the Area (% of total land area) of 1964 in Small states to that in Upper middle income?
Offer a terse response. 1.02. What is the ratio of the Area (% of total land area) in 1961 in Small states to that in World?
Keep it short and to the point. 0.97. What is the ratio of the Area (% of total land area) in 1962 in Small states to that in World?
Make the answer very short. 0.97. What is the ratio of the Area (% of total land area) in 1963 in Small states to that in World?
Ensure brevity in your answer.  0.96. What is the ratio of the Area (% of total land area) of 1964 in Small states to that in World?
Ensure brevity in your answer.  0.96. What is the ratio of the Area (% of total land area) of 1961 in South Asia to that in Sub-Saharan Africa (all income levels)?
Your response must be concise. 1.38. What is the ratio of the Area (% of total land area) in 1962 in South Asia to that in Sub-Saharan Africa (all income levels)?
Provide a succinct answer. 1.39. What is the ratio of the Area (% of total land area) of 1963 in South Asia to that in Sub-Saharan Africa (all income levels)?
Offer a terse response. 1.38. What is the ratio of the Area (% of total land area) of 1964 in South Asia to that in Sub-Saharan Africa (all income levels)?
Your response must be concise. 1.39. What is the ratio of the Area (% of total land area) of 1961 in South Asia to that in Sub-Saharan Africa (developing only)?
Your answer should be very brief. 1.38. What is the ratio of the Area (% of total land area) in 1962 in South Asia to that in Sub-Saharan Africa (developing only)?
Your answer should be compact. 1.39. What is the ratio of the Area (% of total land area) in 1963 in South Asia to that in Sub-Saharan Africa (developing only)?
Offer a terse response. 1.38. What is the ratio of the Area (% of total land area) of 1964 in South Asia to that in Sub-Saharan Africa (developing only)?
Your answer should be compact. 1.39. What is the ratio of the Area (% of total land area) in 1961 in South Asia to that in Upper middle income?
Offer a terse response. 1.65. What is the ratio of the Area (% of total land area) in 1962 in South Asia to that in Upper middle income?
Make the answer very short. 1.65. What is the ratio of the Area (% of total land area) in 1963 in South Asia to that in Upper middle income?
Ensure brevity in your answer.  1.63. What is the ratio of the Area (% of total land area) of 1964 in South Asia to that in Upper middle income?
Provide a short and direct response. 1.63. What is the ratio of the Area (% of total land area) in 1961 in South Asia to that in World?
Your answer should be very brief. 1.53. What is the ratio of the Area (% of total land area) in 1962 in South Asia to that in World?
Your answer should be very brief. 1.54. What is the ratio of the Area (% of total land area) in 1963 in South Asia to that in World?
Ensure brevity in your answer.  1.53. What is the ratio of the Area (% of total land area) in 1964 in South Asia to that in World?
Your response must be concise. 1.53. What is the ratio of the Area (% of total land area) in 1961 in Sub-Saharan Africa (all income levels) to that in Sub-Saharan Africa (developing only)?
Your answer should be compact. 1. What is the ratio of the Area (% of total land area) in 1962 in Sub-Saharan Africa (all income levels) to that in Sub-Saharan Africa (developing only)?
Give a very brief answer. 1. What is the ratio of the Area (% of total land area) in 1964 in Sub-Saharan Africa (all income levels) to that in Sub-Saharan Africa (developing only)?
Ensure brevity in your answer.  1. What is the ratio of the Area (% of total land area) in 1961 in Sub-Saharan Africa (all income levels) to that in Upper middle income?
Your response must be concise. 1.19. What is the ratio of the Area (% of total land area) of 1962 in Sub-Saharan Africa (all income levels) to that in Upper middle income?
Your answer should be very brief. 1.19. What is the ratio of the Area (% of total land area) of 1963 in Sub-Saharan Africa (all income levels) to that in Upper middle income?
Make the answer very short. 1.18. What is the ratio of the Area (% of total land area) in 1964 in Sub-Saharan Africa (all income levels) to that in Upper middle income?
Make the answer very short. 1.18. What is the ratio of the Area (% of total land area) of 1961 in Sub-Saharan Africa (all income levels) to that in World?
Give a very brief answer. 1.11. What is the ratio of the Area (% of total land area) in 1962 in Sub-Saharan Africa (all income levels) to that in World?
Provide a short and direct response. 1.11. What is the ratio of the Area (% of total land area) of 1963 in Sub-Saharan Africa (all income levels) to that in World?
Your answer should be very brief. 1.11. What is the ratio of the Area (% of total land area) of 1964 in Sub-Saharan Africa (all income levels) to that in World?
Give a very brief answer. 1.11. What is the ratio of the Area (% of total land area) in 1961 in Sub-Saharan Africa (developing only) to that in Upper middle income?
Provide a succinct answer. 1.2. What is the ratio of the Area (% of total land area) in 1962 in Sub-Saharan Africa (developing only) to that in Upper middle income?
Your answer should be very brief. 1.19. What is the ratio of the Area (% of total land area) of 1963 in Sub-Saharan Africa (developing only) to that in Upper middle income?
Your answer should be very brief. 1.18. What is the ratio of the Area (% of total land area) of 1964 in Sub-Saharan Africa (developing only) to that in Upper middle income?
Provide a succinct answer. 1.18. What is the ratio of the Area (% of total land area) of 1961 in Sub-Saharan Africa (developing only) to that in World?
Give a very brief answer. 1.11. What is the ratio of the Area (% of total land area) in 1962 in Sub-Saharan Africa (developing only) to that in World?
Your answer should be very brief. 1.11. What is the ratio of the Area (% of total land area) of 1963 in Sub-Saharan Africa (developing only) to that in World?
Offer a terse response. 1.11. What is the ratio of the Area (% of total land area) of 1964 in Sub-Saharan Africa (developing only) to that in World?
Offer a terse response. 1.11. What is the ratio of the Area (% of total land area) of 1961 in Upper middle income to that in World?
Your response must be concise. 0.93. What is the ratio of the Area (% of total land area) of 1962 in Upper middle income to that in World?
Your answer should be very brief. 0.93. What is the ratio of the Area (% of total land area) in 1963 in Upper middle income to that in World?
Your answer should be very brief. 0.94. What is the ratio of the Area (% of total land area) of 1964 in Upper middle income to that in World?
Offer a very short reply. 0.94. What is the difference between the highest and the second highest Area (% of total land area) of 1961?
Make the answer very short. 15.12. What is the difference between the highest and the second highest Area (% of total land area) of 1962?
Your answer should be compact. 15.44. What is the difference between the highest and the second highest Area (% of total land area) in 1963?
Offer a terse response. 15.35. What is the difference between the highest and the second highest Area (% of total land area) of 1964?
Make the answer very short. 15.56. What is the difference between the highest and the lowest Area (% of total land area) of 1961?
Offer a very short reply. 21.66. What is the difference between the highest and the lowest Area (% of total land area) in 1962?
Provide a short and direct response. 21.78. What is the difference between the highest and the lowest Area (% of total land area) of 1963?
Offer a terse response. 21.54. What is the difference between the highest and the lowest Area (% of total land area) of 1964?
Offer a terse response. 21.57. 